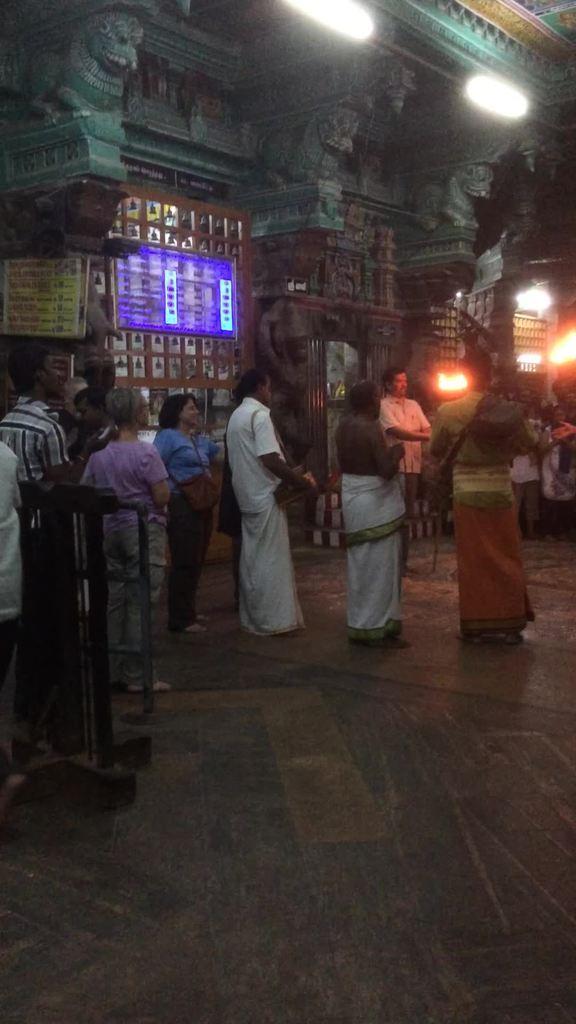How would you summarize this image in a sentence or two? In this image I can see a group of people are standing on the floor and a fence. In the background I can see a wall, boards, lights, lamps and sculptures on a wall. This image is taken may be in a temple during night. 